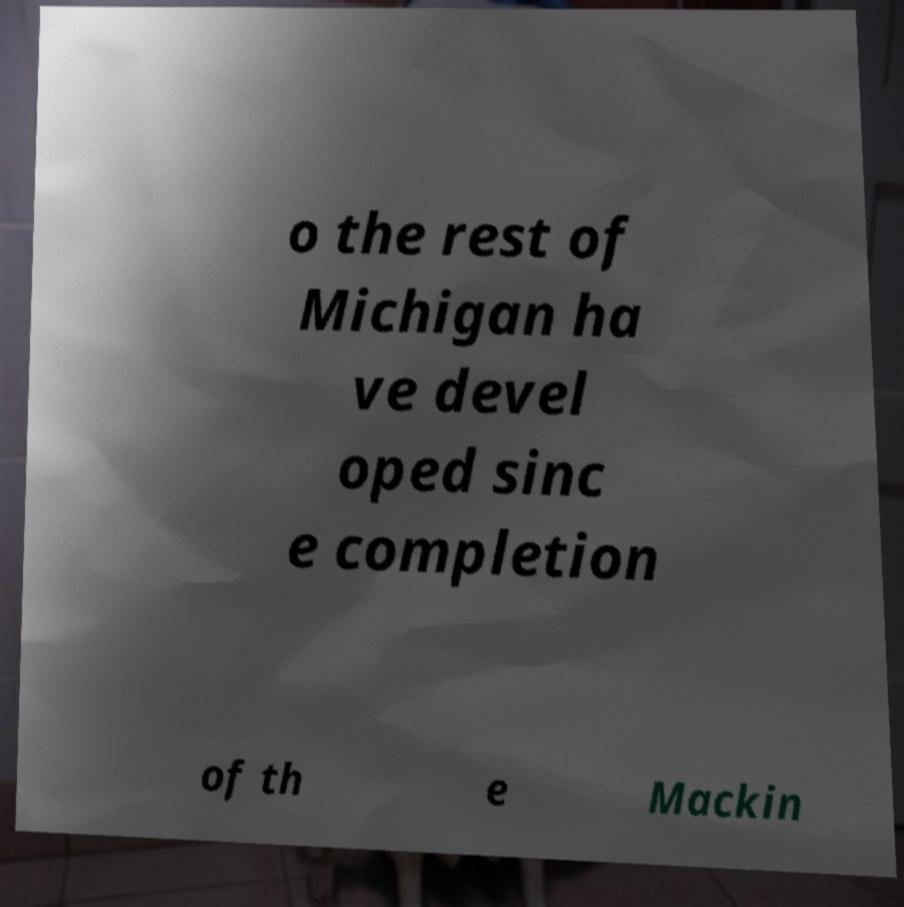Could you assist in decoding the text presented in this image and type it out clearly? o the rest of Michigan ha ve devel oped sinc e completion of th e Mackin 